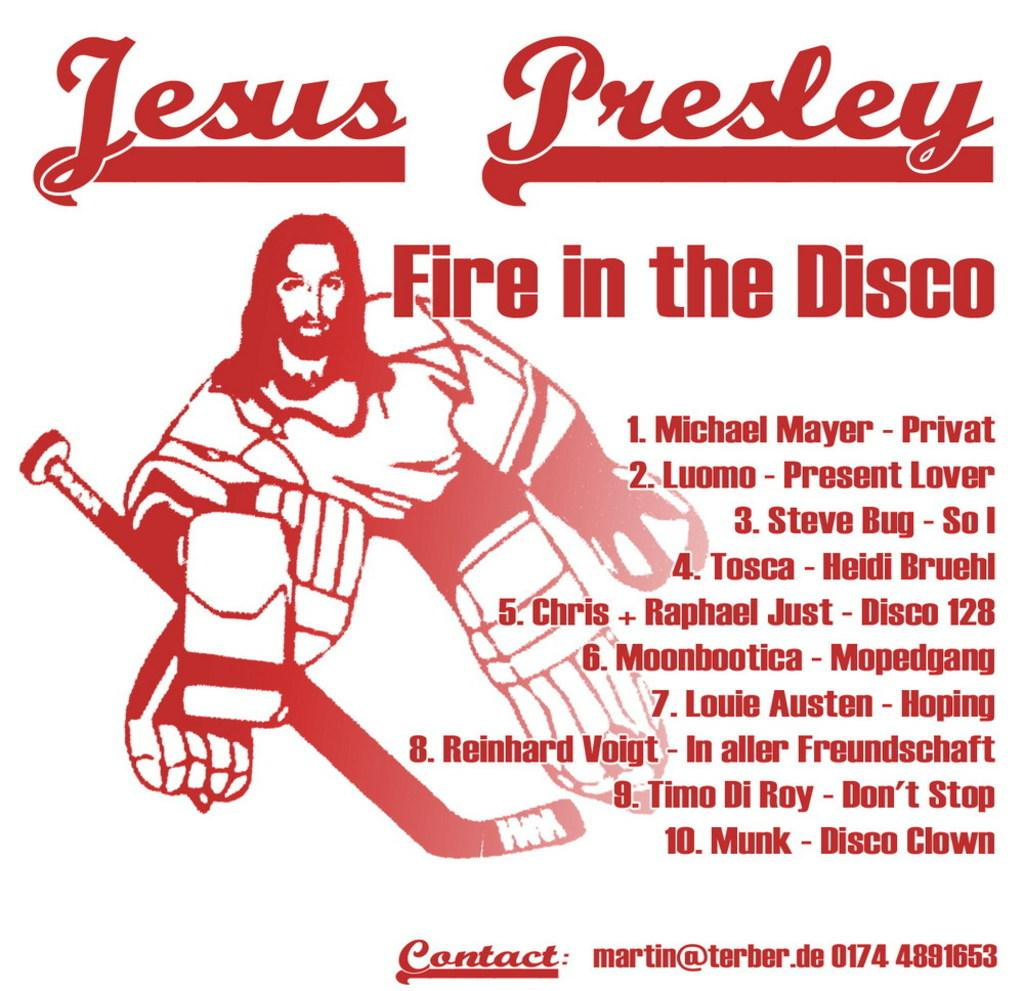<image>
Give a short and clear explanation of the subsequent image. A poster for Jesus Presley Fire in the Disco with a picture of Jesus in hockey gear. 